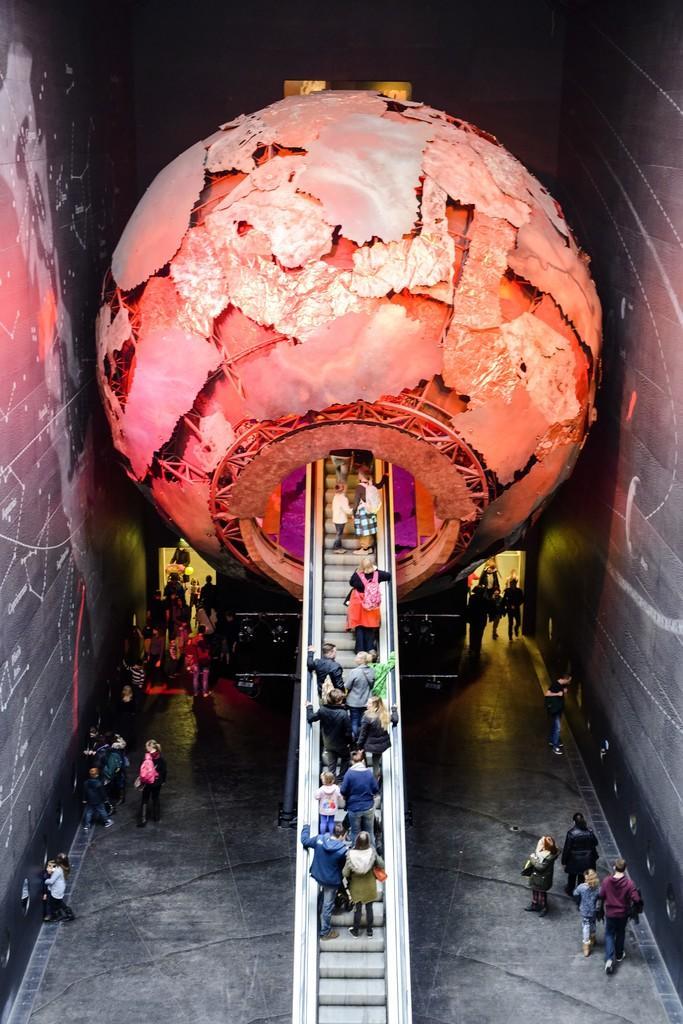Could you give a brief overview of what you see in this image? In this picture I can observe a sphere and staircase in the middle of the picture. On either sides of the picture I can observe some people on the floor. The background is dark. 